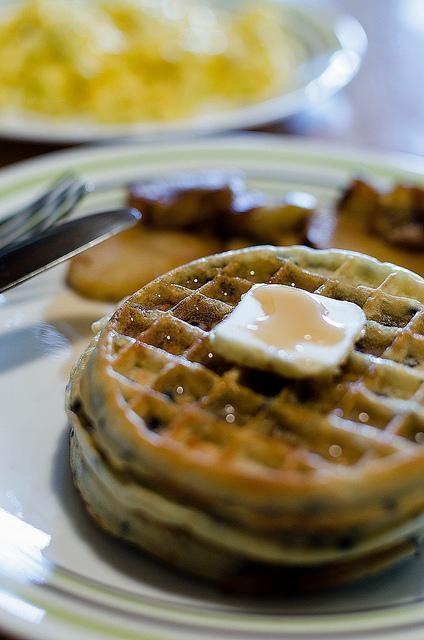How many people are holding a bat?
Give a very brief answer. 0. 